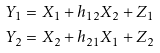<formula> <loc_0><loc_0><loc_500><loc_500>Y _ { 1 } = & \ X _ { 1 } + h _ { 1 2 } X _ { 2 } + Z _ { 1 } \\ Y _ { 2 } = & \ X _ { 2 } + h _ { 2 1 } X _ { 1 } + Z _ { 2 }</formula> 